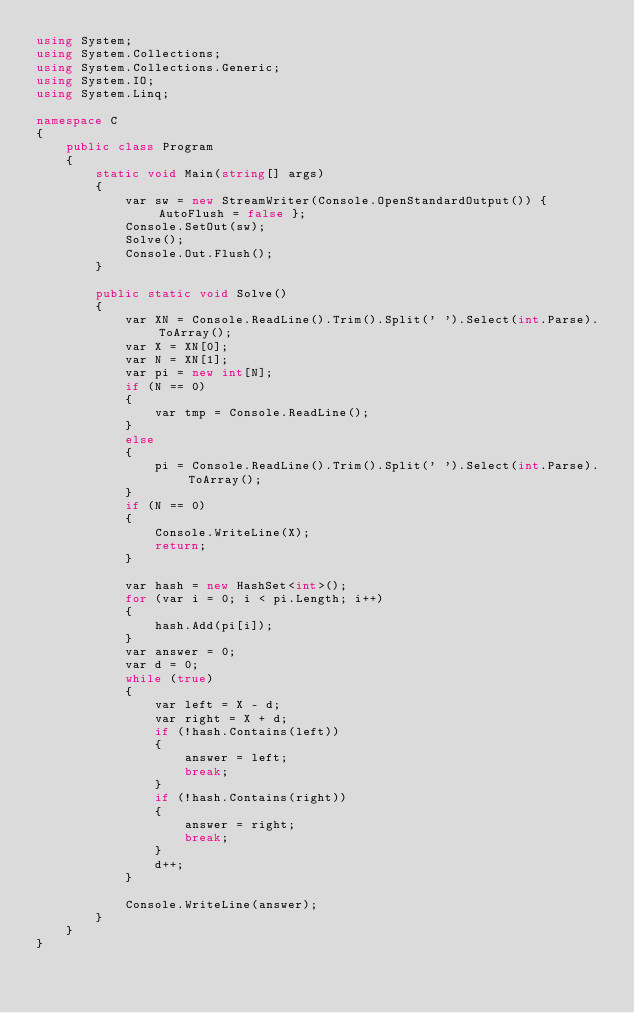<code> <loc_0><loc_0><loc_500><loc_500><_C#_>using System;
using System.Collections;
using System.Collections.Generic;
using System.IO;
using System.Linq;

namespace C
{
    public class Program
    {
        static void Main(string[] args)
        {
            var sw = new StreamWriter(Console.OpenStandardOutput()) { AutoFlush = false };
            Console.SetOut(sw);
            Solve();
            Console.Out.Flush();
        }

        public static void Solve()
        {
            var XN = Console.ReadLine().Trim().Split(' ').Select(int.Parse).ToArray();
            var X = XN[0];
            var N = XN[1];
            var pi = new int[N];
            if (N == 0)
            {
                var tmp = Console.ReadLine();
            }
            else
            {
                pi = Console.ReadLine().Trim().Split(' ').Select(int.Parse).ToArray();
            }
            if (N == 0)
            {
                Console.WriteLine(X);
                return;
            }

            var hash = new HashSet<int>();
            for (var i = 0; i < pi.Length; i++)
            {
                hash.Add(pi[i]);
            }
            var answer = 0;
            var d = 0;
            while (true)
            {
                var left = X - d;
                var right = X + d;
                if (!hash.Contains(left))
                {
                    answer = left;
                    break;
                }
                if (!hash.Contains(right))
                {
                    answer = right;
                    break;
                }
                d++;
            }

            Console.WriteLine(answer);
        }
    }
}
</code> 